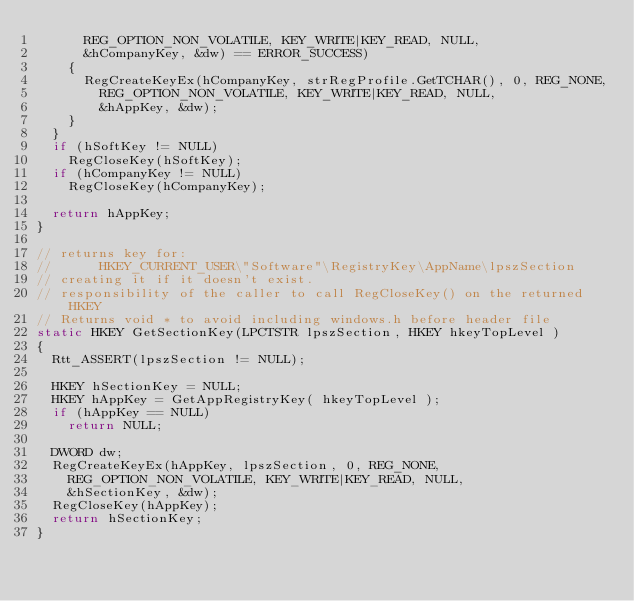<code> <loc_0><loc_0><loc_500><loc_500><_C++_>			REG_OPTION_NON_VOLATILE, KEY_WRITE|KEY_READ, NULL,
			&hCompanyKey, &dw) == ERROR_SUCCESS)
		{
			RegCreateKeyEx(hCompanyKey, strRegProfile.GetTCHAR(), 0, REG_NONE,
				REG_OPTION_NON_VOLATILE, KEY_WRITE|KEY_READ, NULL,
				&hAppKey, &dw);
		}
	}
	if (hSoftKey != NULL)
		RegCloseKey(hSoftKey);
	if (hCompanyKey != NULL)
		RegCloseKey(hCompanyKey);

	return hAppKey;
}

// returns key for:
//      HKEY_CURRENT_USER\"Software"\RegistryKey\AppName\lpszSection
// creating it if it doesn't exist.
// responsibility of the caller to call RegCloseKey() on the returned HKEY
// Returns void * to avoid including windows.h before header file
static HKEY GetSectionKey(LPCTSTR lpszSection, HKEY hkeyTopLevel )
{
	Rtt_ASSERT(lpszSection != NULL);

	HKEY hSectionKey = NULL;
	HKEY hAppKey = GetAppRegistryKey( hkeyTopLevel );
	if (hAppKey == NULL)
		return NULL;

	DWORD dw;
	RegCreateKeyEx(hAppKey, lpszSection, 0, REG_NONE,
		REG_OPTION_NON_VOLATILE, KEY_WRITE|KEY_READ, NULL,
		&hSectionKey, &dw);
	RegCloseKey(hAppKey);
	return hSectionKey;
}
</code> 